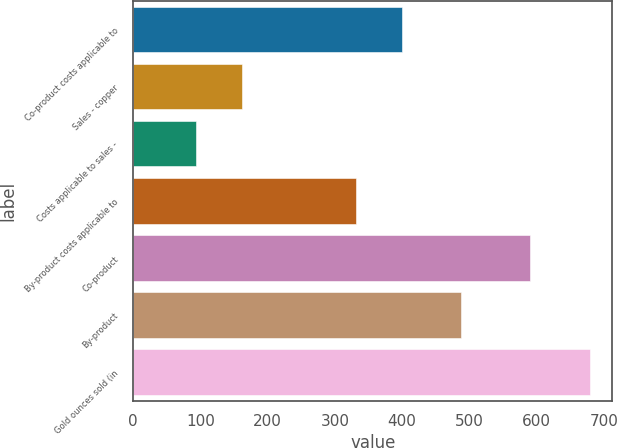Convert chart to OTSL. <chart><loc_0><loc_0><loc_500><loc_500><bar_chart><fcel>Co-product costs applicable to<fcel>Sales - copper<fcel>Costs applicable to sales -<fcel>By-product costs applicable to<fcel>Co-product<fcel>By-product<fcel>Gold ounces sold (in<nl><fcel>400<fcel>162<fcel>93<fcel>331<fcel>590<fcel>487<fcel>679<nl></chart> 